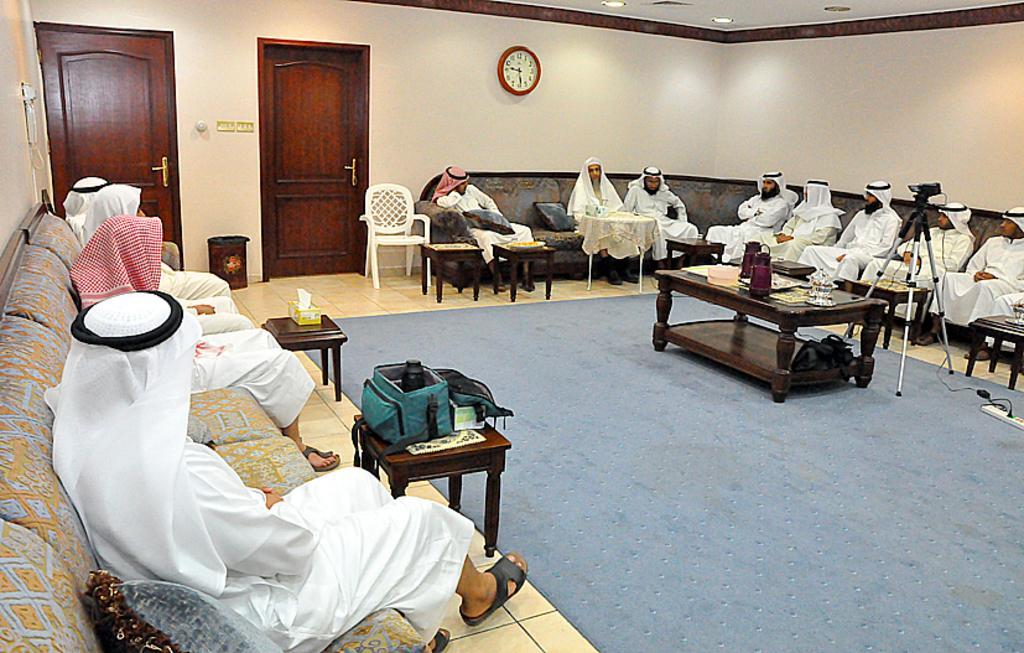Please provide a concise description of this image. This is a picture taken in a room, there are a group of people sitting on sofas in front of these people there is a tables on the tables there are bag, tissue box, jar and cup and the floor is covered with mat. On the floor there are tripod stand with camera and the extension box. Behind the people there are two wooden doors and a wall with clock. There are ceiling lights on the top. 